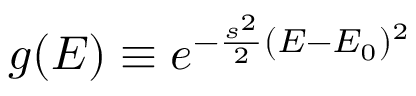Convert formula to latex. <formula><loc_0><loc_0><loc_500><loc_500>g ( E ) \equiv e ^ { - \frac { s ^ { 2 } } { 2 } ( E - E _ { 0 } ) ^ { 2 } }</formula> 